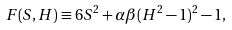<formula> <loc_0><loc_0><loc_500><loc_500>F ( S , H ) \equiv 6 S ^ { 2 } + \alpha \beta ( H ^ { 2 } - 1 ) ^ { 2 } - 1 ,</formula> 